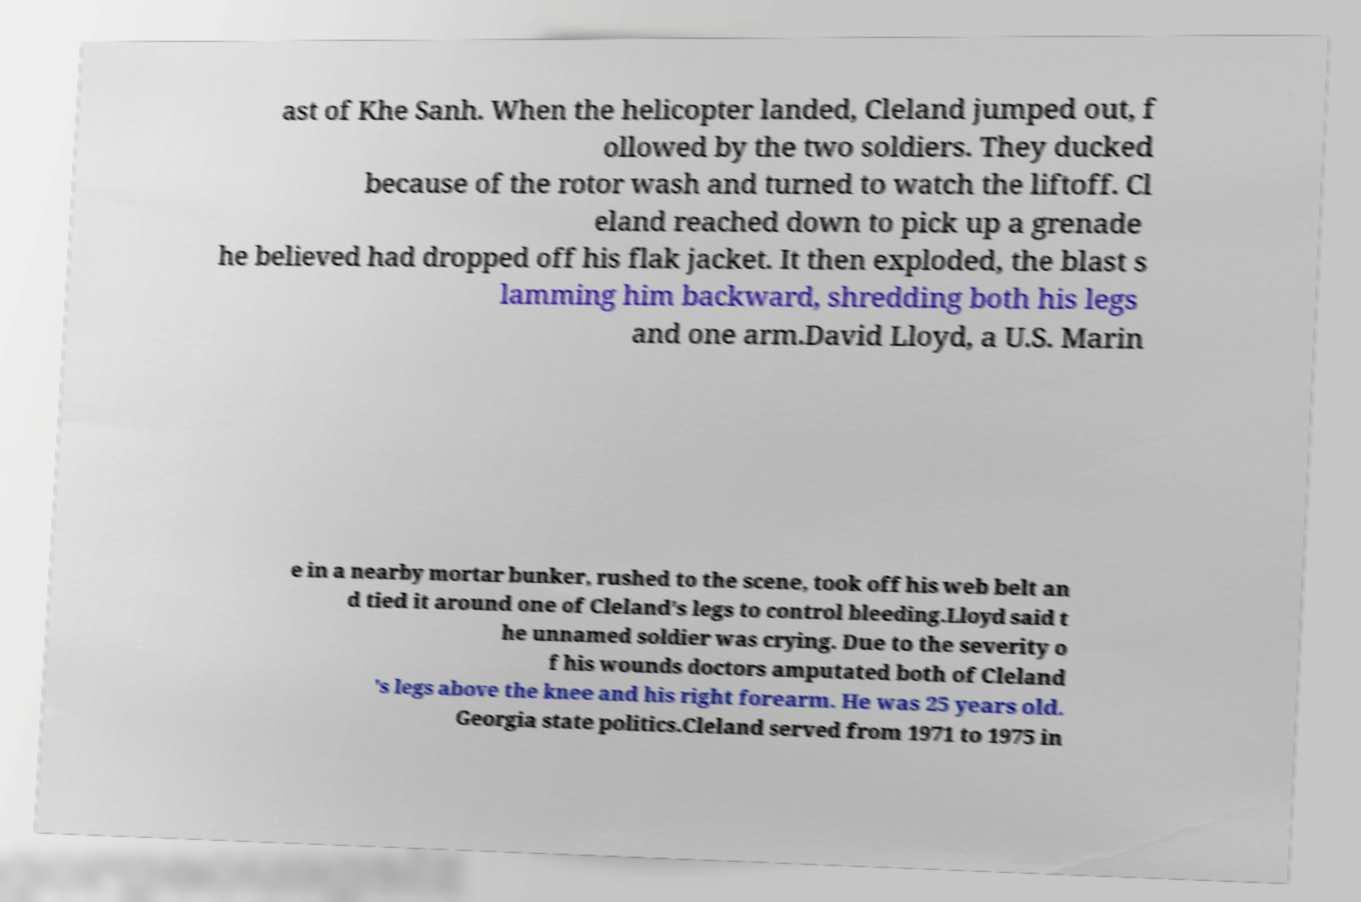Could you assist in decoding the text presented in this image and type it out clearly? ast of Khe Sanh. When the helicopter landed, Cleland jumped out, f ollowed by the two soldiers. They ducked because of the rotor wash and turned to watch the liftoff. Cl eland reached down to pick up a grenade he believed had dropped off his flak jacket. It then exploded, the blast s lamming him backward, shredding both his legs and one arm.David Lloyd, a U.S. Marin e in a nearby mortar bunker, rushed to the scene, took off his web belt an d tied it around one of Cleland's legs to control bleeding.Lloyd said t he unnamed soldier was crying. Due to the severity o f his wounds doctors amputated both of Cleland 's legs above the knee and his right forearm. He was 25 years old. Georgia state politics.Cleland served from 1971 to 1975 in 